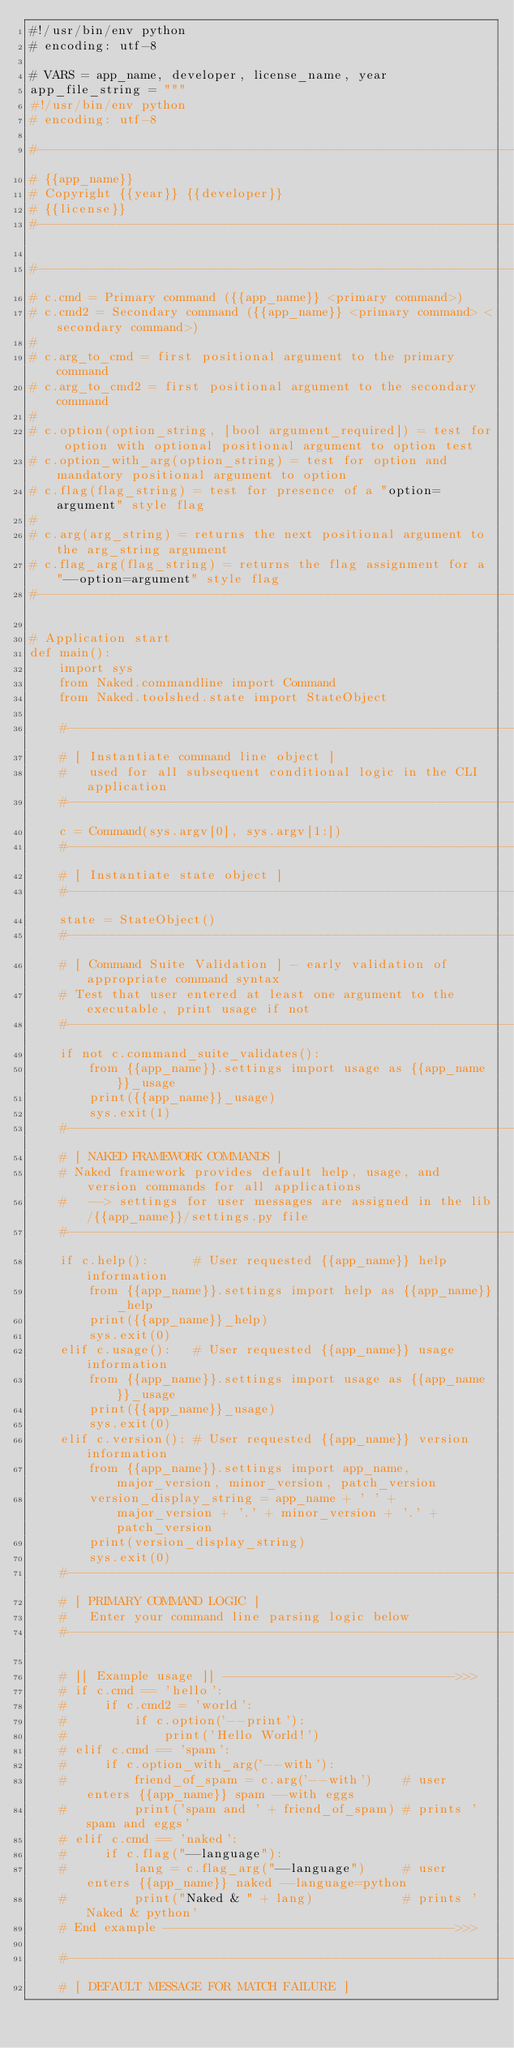Convert code to text. <code><loc_0><loc_0><loc_500><loc_500><_Python_>#!/usr/bin/env python
# encoding: utf-8

# VARS = app_name, developer, license_name, year
app_file_string = """
#!/usr/bin/env python
# encoding: utf-8

#------------------------------------------------------------------------------
# {{app_name}}
# Copyright {{year}} {{developer}}
# {{license}}
#------------------------------------------------------------------------------

#------------------------------------------------------------------------------------
# c.cmd = Primary command ({{app_name}} <primary command>)
# c.cmd2 = Secondary command ({{app_name}} <primary command> <secondary command>)
#
# c.arg_to_cmd = first positional argument to the primary command
# c.arg_to_cmd2 = first positional argument to the secondary command
#
# c.option(option_string, [bool argument_required]) = test for option with optional positional argument to option test
# c.option_with_arg(option_string) = test for option and mandatory positional argument to option
# c.flag(flag_string) = test for presence of a "option=argument" style flag
#
# c.arg(arg_string) = returns the next positional argument to the arg_string argument
# c.flag_arg(flag_string) = returns the flag assignment for a "--option=argument" style flag
#------------------------------------------------------------------------------------

# Application start
def main():
    import sys
    from Naked.commandline import Command
    from Naked.toolshed.state import StateObject

    #------------------------------------------------------------------------------------------
    # [ Instantiate command line object ]
    #   used for all subsequent conditional logic in the CLI application
    #------------------------------------------------------------------------------------------
    c = Command(sys.argv[0], sys.argv[1:])
    #------------------------------------------------------------------------------
    # [ Instantiate state object ]
    #------------------------------------------------------------------------------
    state = StateObject()
    #------------------------------------------------------------------------------------------
    # [ Command Suite Validation ] - early validation of appropriate command syntax
    # Test that user entered at least one argument to the executable, print usage if not
    #------------------------------------------------------------------------------------------
    if not c.command_suite_validates():
        from {{app_name}}.settings import usage as {{app_name}}_usage
        print({{app_name}}_usage)
        sys.exit(1)
    #------------------------------------------------------------------------------------------
    # [ NAKED FRAMEWORK COMMANDS ]
    # Naked framework provides default help, usage, and version commands for all applications
    #   --> settings for user messages are assigned in the lib/{{app_name}}/settings.py file
    #------------------------------------------------------------------------------------------
    if c.help():      # User requested {{app_name}} help information
        from {{app_name}}.settings import help as {{app_name}}_help
        print({{app_name}}_help)
        sys.exit(0)
    elif c.usage():   # User requested {{app_name}} usage information
        from {{app_name}}.settings import usage as {{app_name}}_usage
        print({{app_name}}_usage)
        sys.exit(0)
    elif c.version(): # User requested {{app_name}} version information
        from {{app_name}}.settings import app_name, major_version, minor_version, patch_version
        version_display_string = app_name + ' ' + major_version + '.' + minor_version + '.' + patch_version
        print(version_display_string)
        sys.exit(0)
    #------------------------------------------------------------------------------------------
    # [ PRIMARY COMMAND LOGIC ]
    #   Enter your command line parsing logic below
    #------------------------------------------------------------------------------------------

    # [[ Example usage ]] ------------------------------->>>
    # if c.cmd == 'hello':
    #     if c.cmd2 = 'world':
    # 	      if c.option('--print'):
    # 		      print('Hello World!')
    # elif c.cmd == 'spam':
    #     if c.option_with_arg('--with'):
    # 		  friend_of_spam = c.arg('--with')    # user enters {{app_name}} spam --with eggs
    # 		  print('spam and ' + friend_of_spam) # prints 'spam and eggs'
    # elif c.cmd == 'naked':
    #     if c.flag("--language"):
    #         lang = c.flag_arg("--language")     # user enters {{app_name}} naked --language=python
    #         print("Naked & " + lang)            # prints 'Naked & python'
    # End example --------------------------------------->>>

    #------------------------------------------------------------------------------------------
    # [ DEFAULT MESSAGE FOR MATCH FAILURE ]</code> 